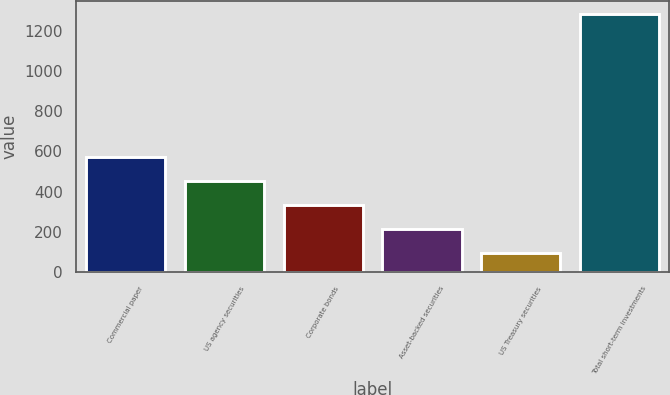<chart> <loc_0><loc_0><loc_500><loc_500><bar_chart><fcel>Commercial paper<fcel>US agency securities<fcel>Corporate bonds<fcel>Asset-backed securities<fcel>US Treasury securities<fcel>Total short-term investments<nl><fcel>575<fcel>451.1<fcel>332.4<fcel>213.7<fcel>95<fcel>1282<nl></chart> 